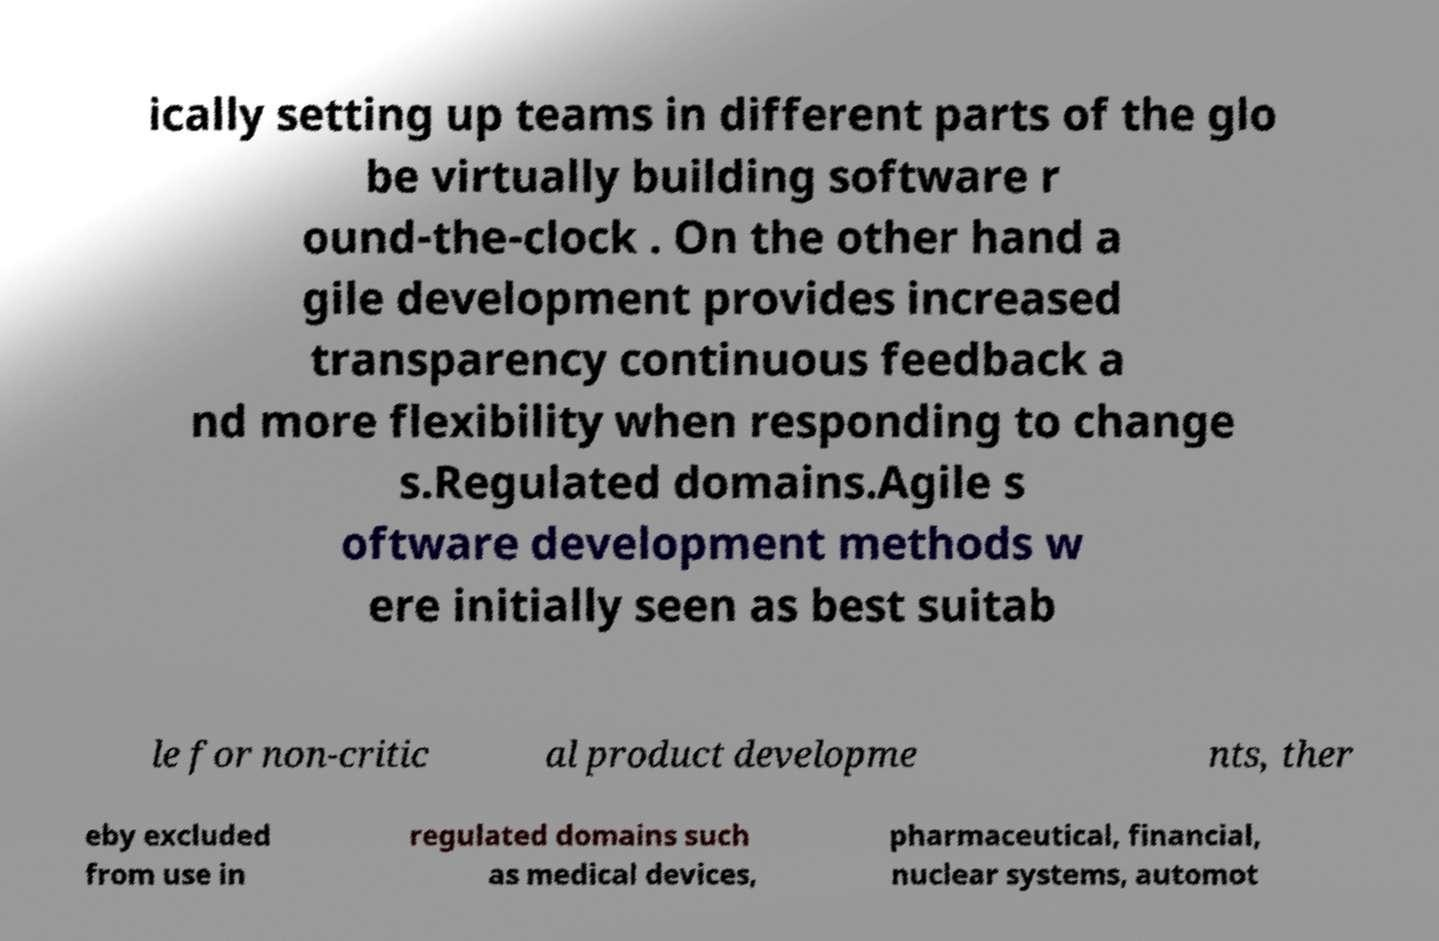Please identify and transcribe the text found in this image. ically setting up teams in different parts of the glo be virtually building software r ound-the-clock . On the other hand a gile development provides increased transparency continuous feedback a nd more flexibility when responding to change s.Regulated domains.Agile s oftware development methods w ere initially seen as best suitab le for non-critic al product developme nts, ther eby excluded from use in regulated domains such as medical devices, pharmaceutical, financial, nuclear systems, automot 